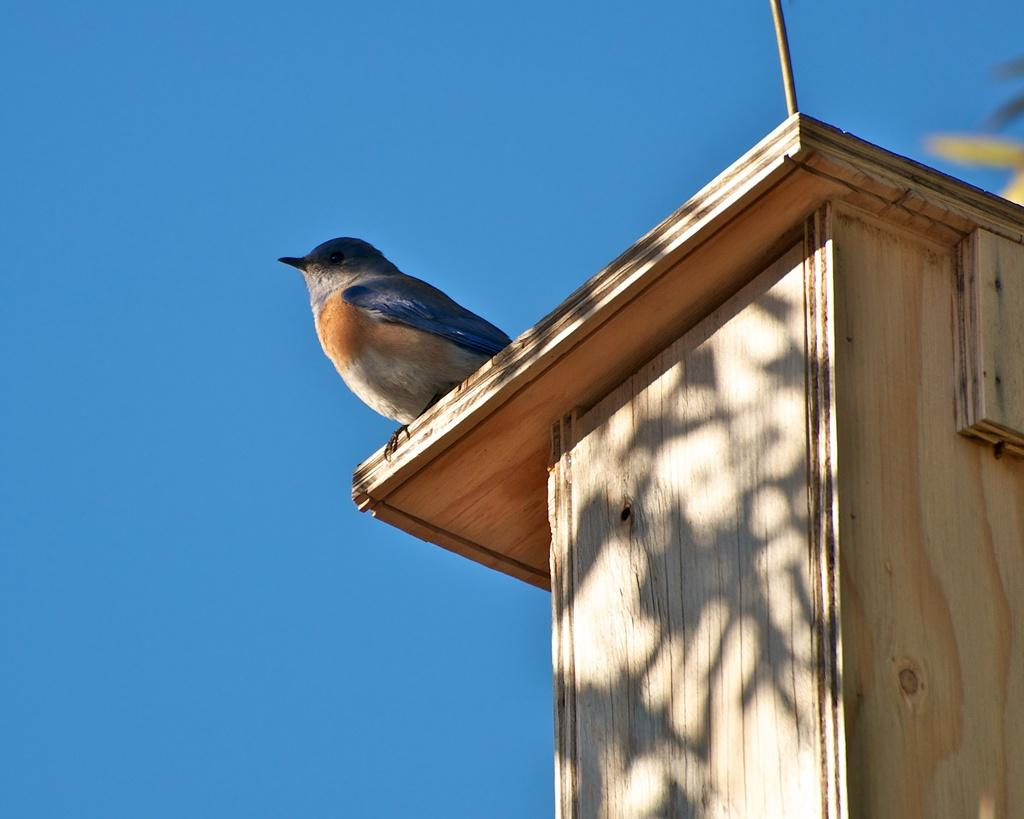What type of animal is in the image? There is a bird in the image. Where is the bird located? The bird is on a wooden box. What can be seen in the background of the image? The background of the image includes the sky. What type of needle is the bird using to sew in the image? There is no needle present in the image, and the bird is not sewing. 